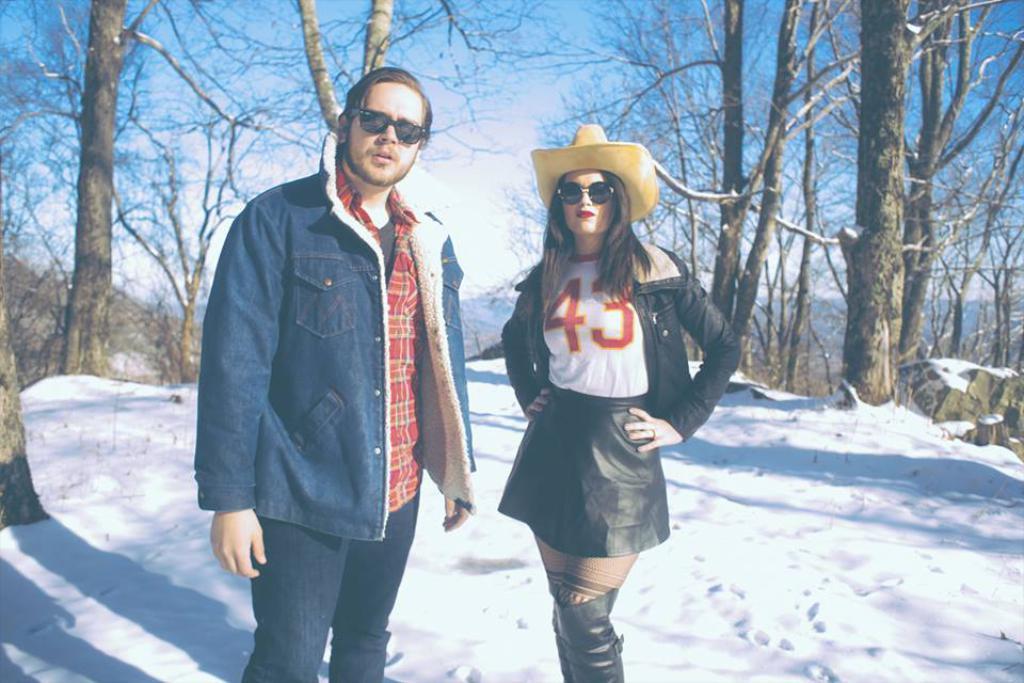Could you give a brief overview of what you see in this image? In this image there is a man and a woman standing on the ground. There is snow on the ground. Behind them there are trees. In the background there are mountains. At the top there is the sky. 